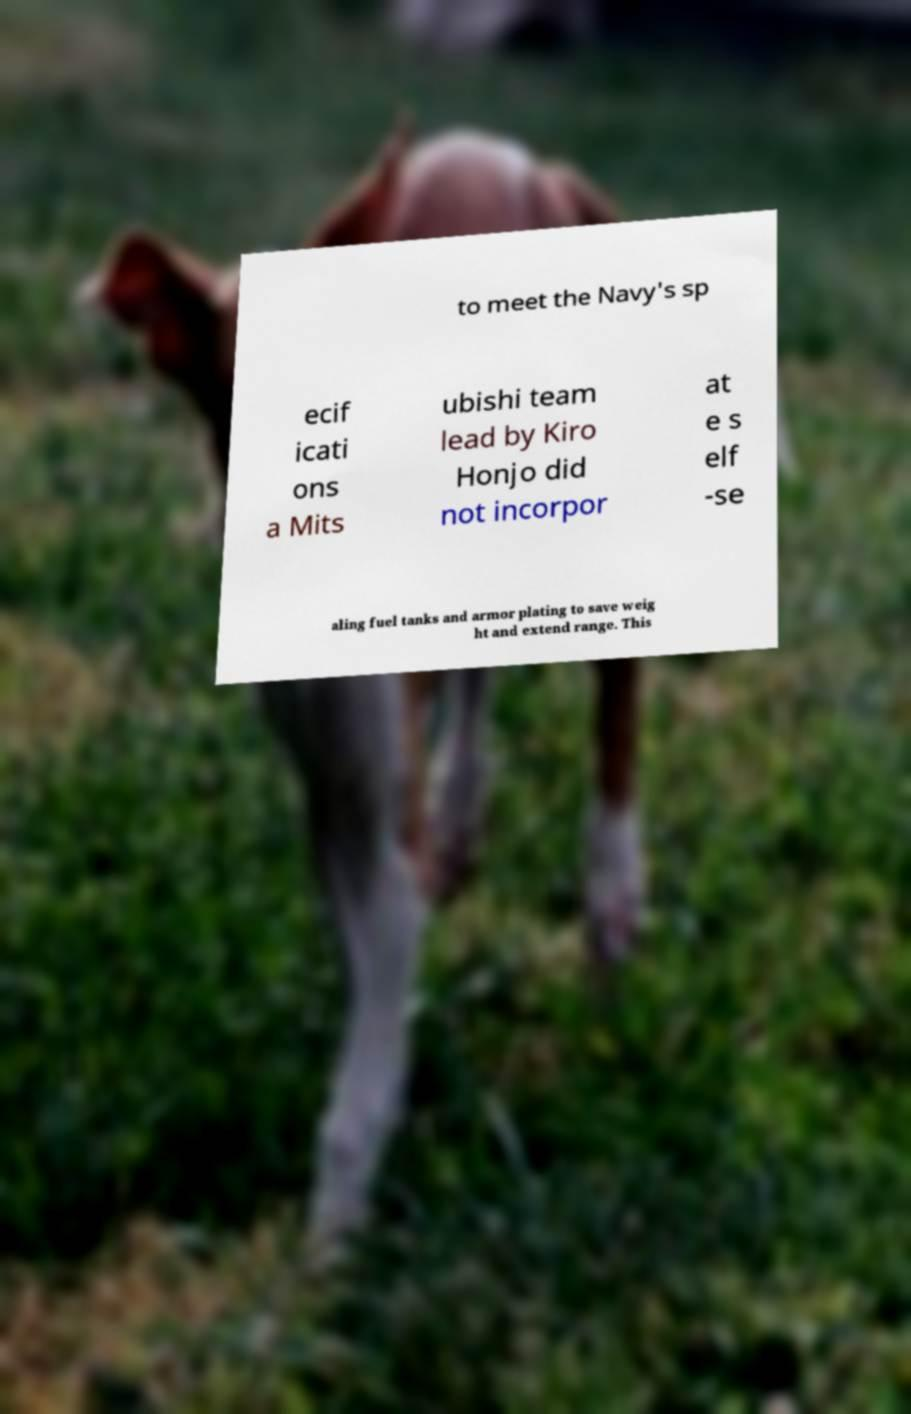Can you read and provide the text displayed in the image?This photo seems to have some interesting text. Can you extract and type it out for me? to meet the Navy's sp ecif icati ons a Mits ubishi team lead by Kiro Honjo did not incorpor at e s elf -se aling fuel tanks and armor plating to save weig ht and extend range. This 